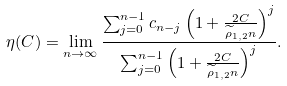Convert formula to latex. <formula><loc_0><loc_0><loc_500><loc_500>\eta ( C ) = \lim _ { n \to \infty } \frac { \sum _ { j = 0 } ^ { n - 1 } c _ { n - j } \left ( 1 + \frac { 2 C } { \widetilde { \rho } _ { 1 , 2 } n } \right ) ^ { j } } { \sum _ { j = 0 } ^ { n - 1 } \left ( 1 + \frac { 2 C } { \widetilde { \rho } _ { 1 , 2 } n } \right ) ^ { j } } .</formula> 